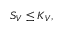<formula> <loc_0><loc_0><loc_500><loc_500>S _ { V } \leq K _ { V } ,</formula> 